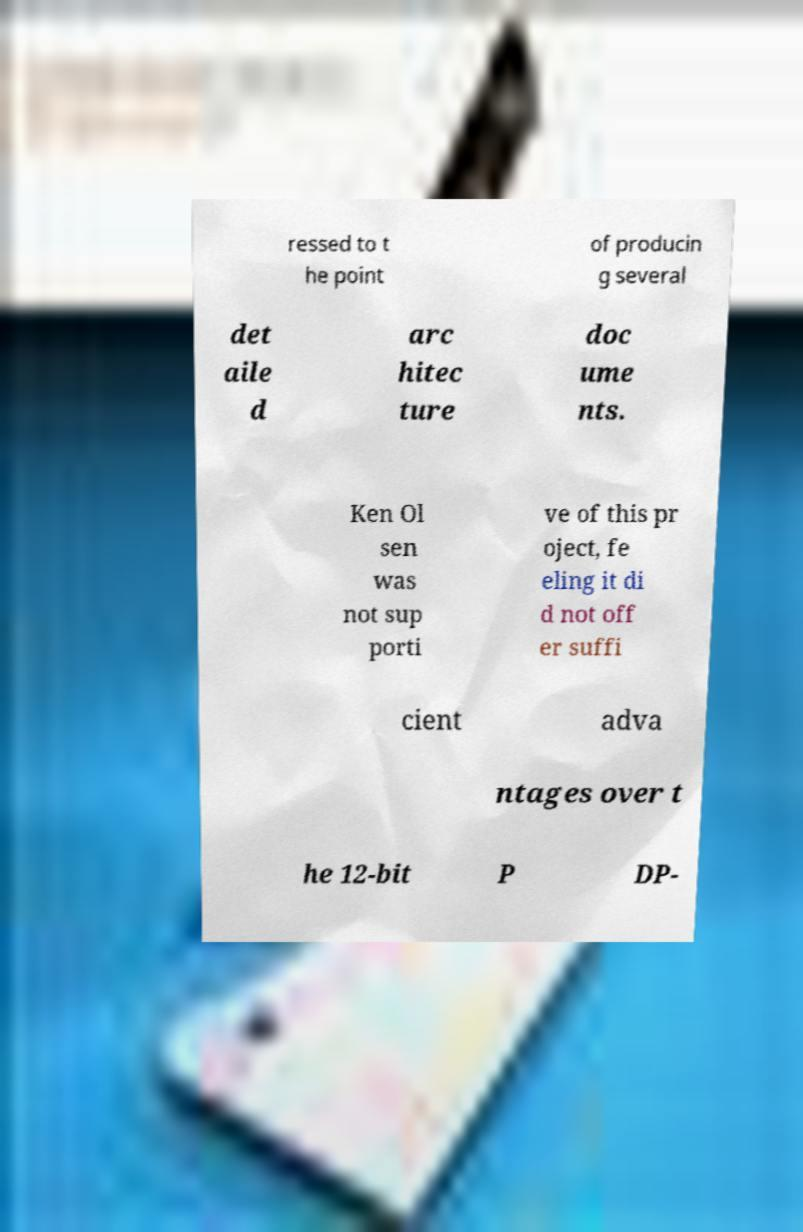Please identify and transcribe the text found in this image. ressed to t he point of producin g several det aile d arc hitec ture doc ume nts. Ken Ol sen was not sup porti ve of this pr oject, fe eling it di d not off er suffi cient adva ntages over t he 12-bit P DP- 